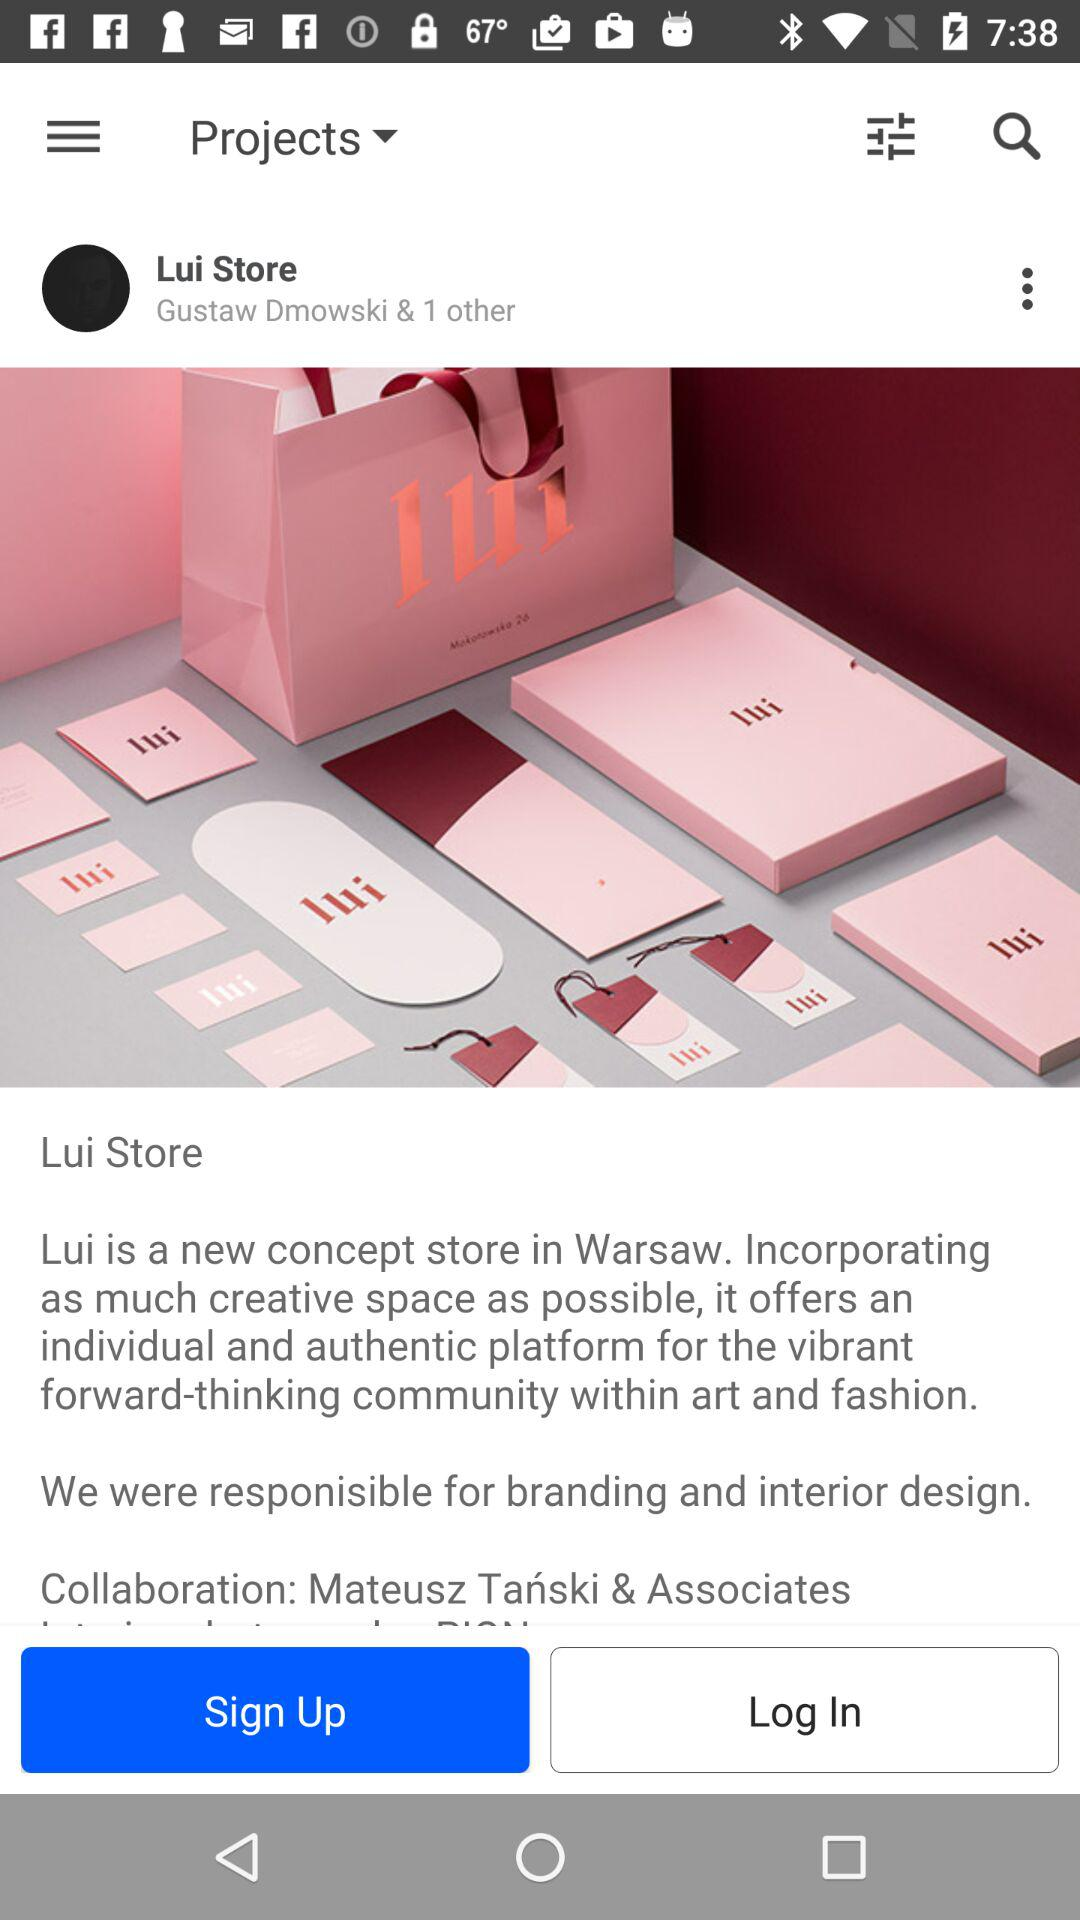Where is the "Lui Store" located? The "Lui Store" is located in Warsaw. 